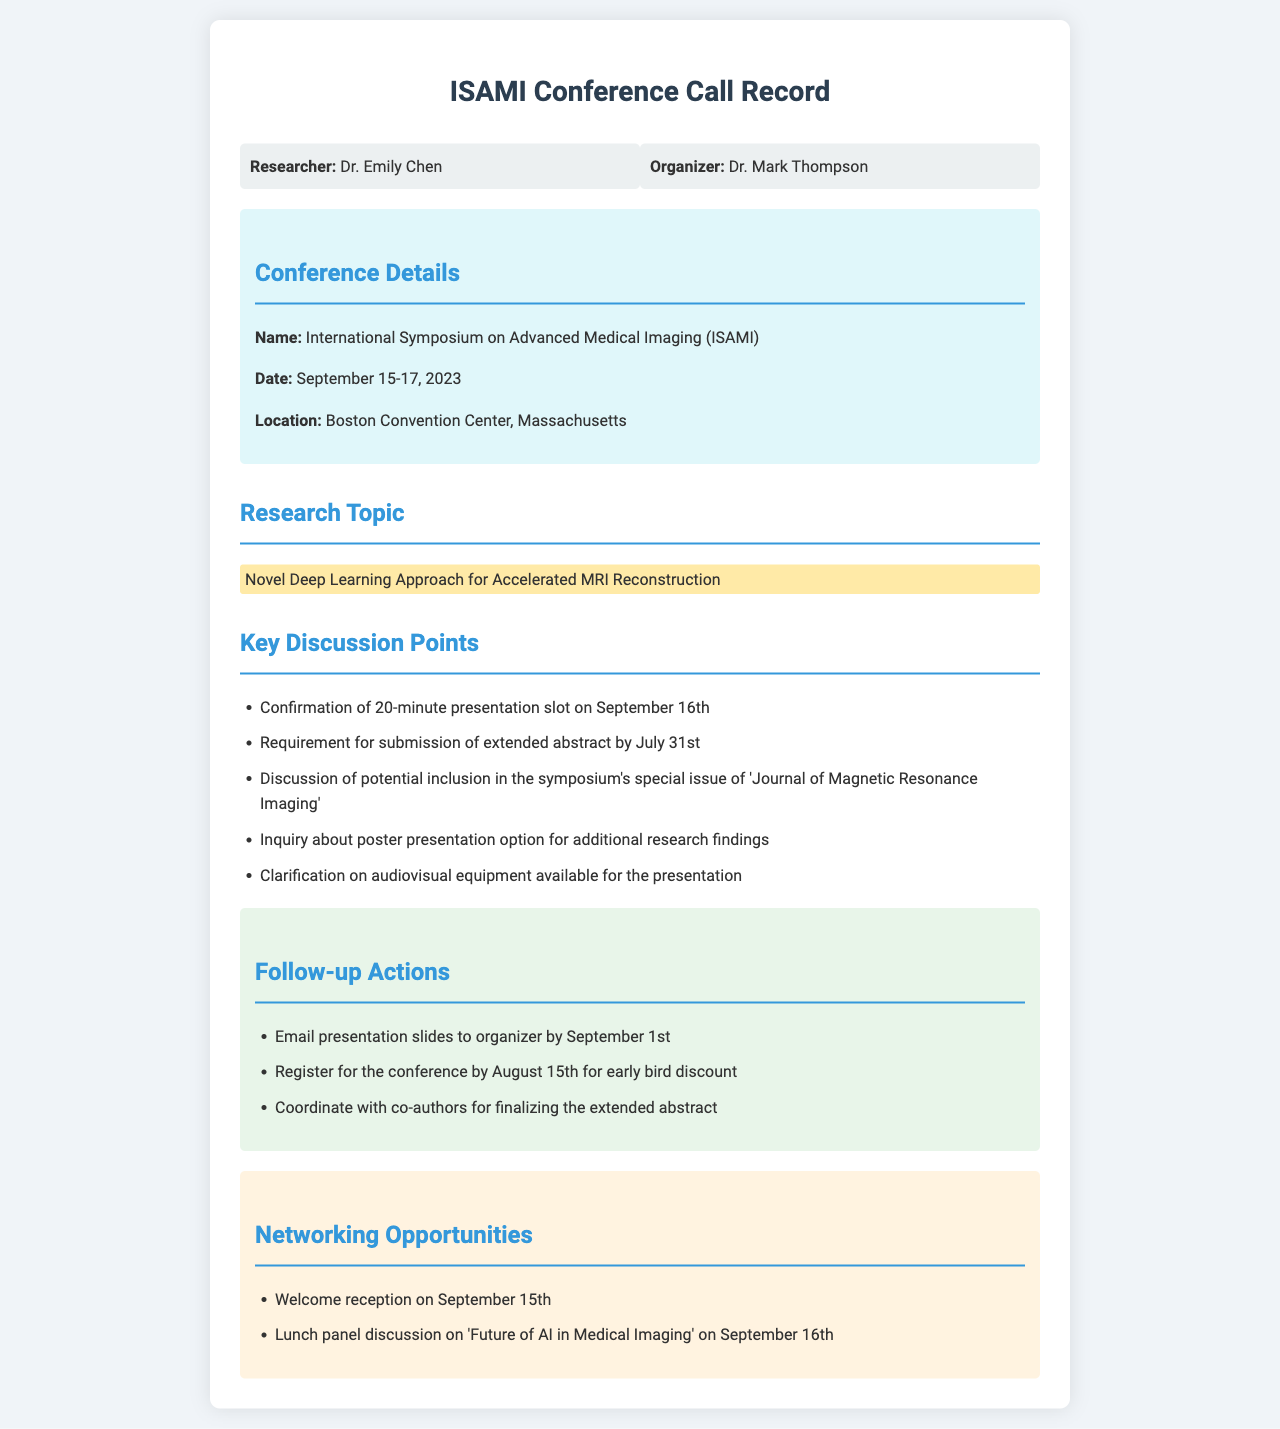What is the name of the conference? The document specifies the conference as the "International Symposium on Advanced Medical Imaging (ISAMI)."
Answer: International Symposium on Advanced Medical Imaging (ISAMI) What are the conference dates? The dates mentioned for the conference are September 15-17, 2023.
Answer: September 15-17, 2023 Who is the organizer of the conference? The document identifies the organizer as Dr. Mark Thompson.
Answer: Dr. Mark Thompson What is the research topic of the presentation? The highlighted research topic is "Novel Deep Learning Approach for Accelerated MRI Reconstruction."
Answer: Novel Deep Learning Approach for Accelerated MRI Reconstruction When is the extended abstract due? The deadline for submitting the extended abstract is July 31st.
Answer: July 31st What audiovisual equipment availability was discussed? The document includes a clarification on the availability of audiovisual equipment for the presentation.
Answer: Clarification on audiovisual equipment What is the early registration deadline for the conference? The document states that registration for the conference must occur by August 15th for the early bird discount.
Answer: August 15th What networking event occurs on September 15th? The document lists a welcome reception as the networking event that occurs on September 15th.
Answer: Welcome reception How long is the presentation slot? The presentation slot confirmed in the document is 20 minutes long.
Answer: 20-minute presentation slot 